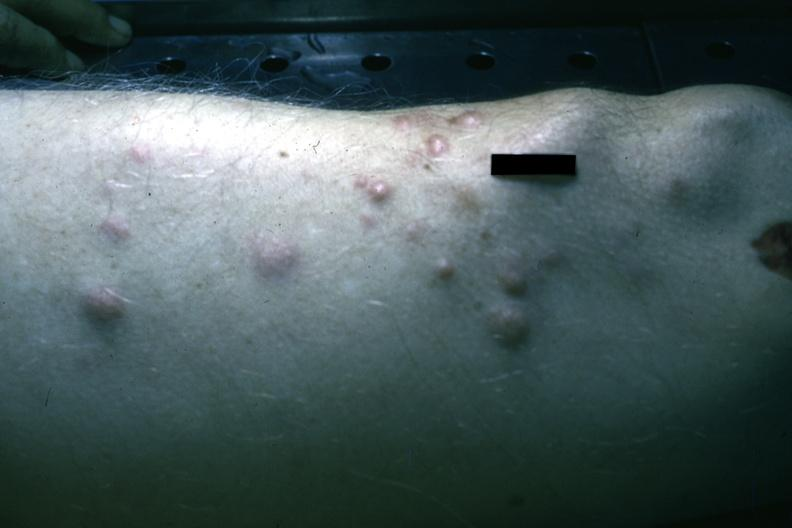what does this image show?
Answer the question using a single word or phrase. Multiple nodular lesions infiltrating neoplastic plasma cells 